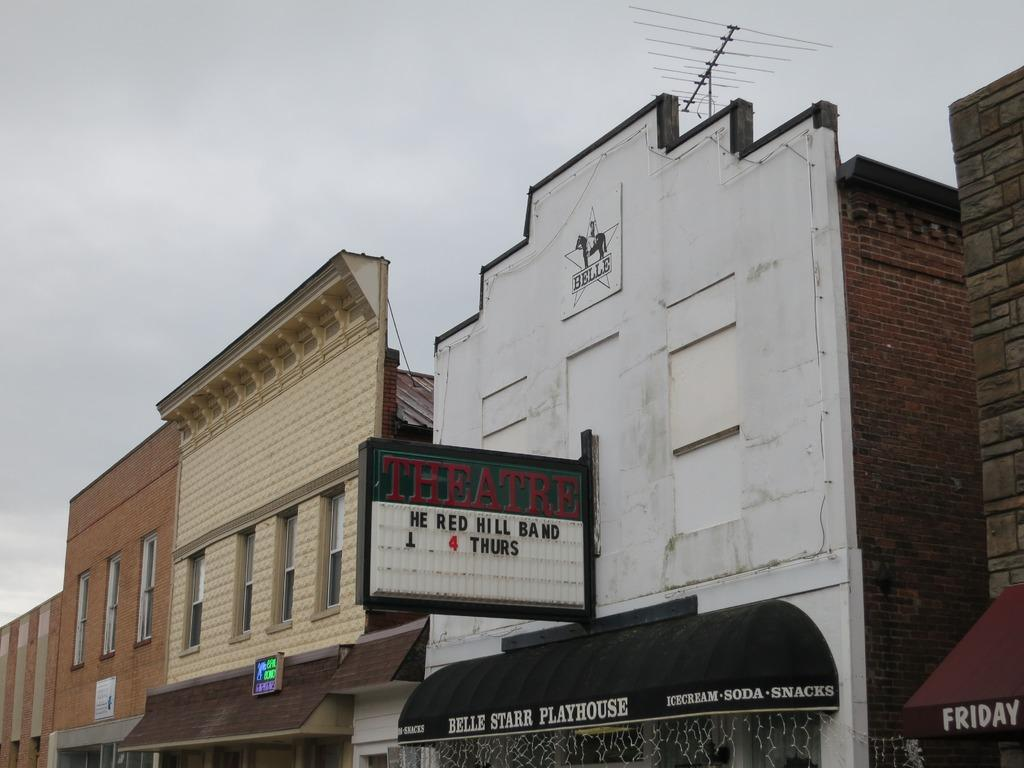What type of structures are present in the image? There are buildings in the image. What features can be observed on the buildings? The buildings have windows and boards. What is written or displayed on the boards? There is text on the boards. What is visible at the top of the image? The sky is visible at the top of the image. How many bears can be seen walking on the railway in the image? There are no bears or railway present in the image; it features buildings with windows and boards. What is the reason for the buildings having boards in the image? The provided facts do not mention a reason for the boards on the buildings, so we cannot determine the reason from the image. 